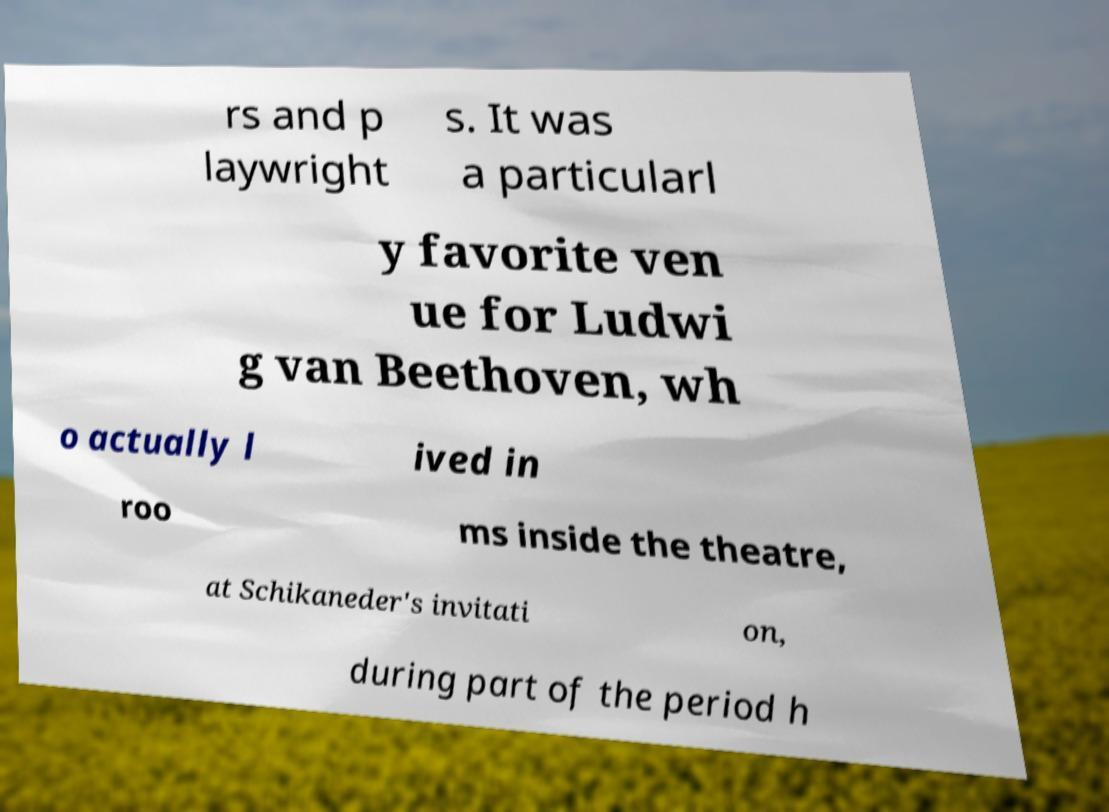Please identify and transcribe the text found in this image. rs and p laywright s. It was a particularl y favorite ven ue for Ludwi g van Beethoven, wh o actually l ived in roo ms inside the theatre, at Schikaneder's invitati on, during part of the period h 